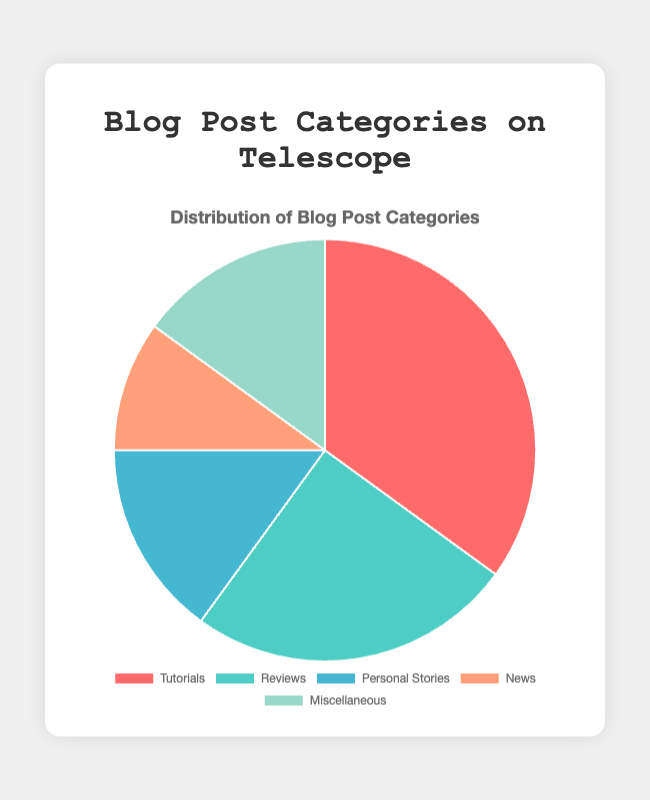What is the most common category of blog posts? The figure shows a pie chart with different categories and their corresponding percentages. By scanning the chart, we see that the category with the highest percentage is "Tutorials" at 35%.
Answer: Tutorials Which blog post categories have an equal percentage? Look for categories with the same percentage on the pie chart. "Personal Stories" and "Miscellaneous" both have 15%.
Answer: Personal Stories and Miscellaneous How much more frequent are Tutorials compared to News posts? From the pie chart, we see Tutorials have 35% and News has 10%. The difference is 35% - 10% = 25%.
Answer: 25% What is the sum of the percentages for Reviews and News combined? The pie chart shows Reviews at 25% and News at 10%. Summing these values gives 25% + 10% = 35%.
Answer: 35% By how much does the percentage of Reviews exceed the percentage of Personal Stories? The pie chart shows Reviews at 25% and Personal Stories at 15%. The difference is 25% - 15% = 10%.
Answer: 10% What is the second most common category of blog posts? After Tutorials (35%), the next highest percentage is Reviews at 25%.
Answer: Reviews What is the combined percentage of the least three common categories? The least three common categories are Personal Stories (15%), News (10%), and Miscellaneous (15%). Adding them gives 15% + 10% + 15% = 40%.
Answer: 40% Which category occupies the smallest segment, and what is its color? The smallest segment in the pie chart represents "News" at 10%. It is colored in a light orange shade.
Answer: News, light orange How does the percentage of Miscellaneous compare to that of Tutorials? Tutorials have 35% and Miscellaneous have 15%. By comparing the values, we see that 35% is more than 15%.
Answer: Tutorials have a higher percentage than Miscellaneous 